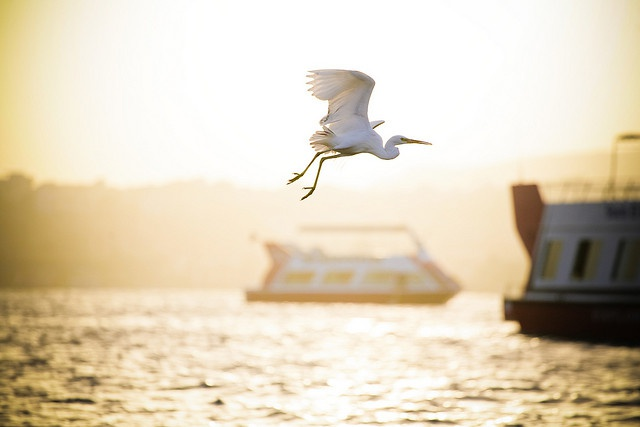Describe the objects in this image and their specific colors. I can see boat in khaki, black, gray, maroon, and tan tones, boat in khaki, tan, and beige tones, and bird in khaki, darkgray, tan, and white tones in this image. 